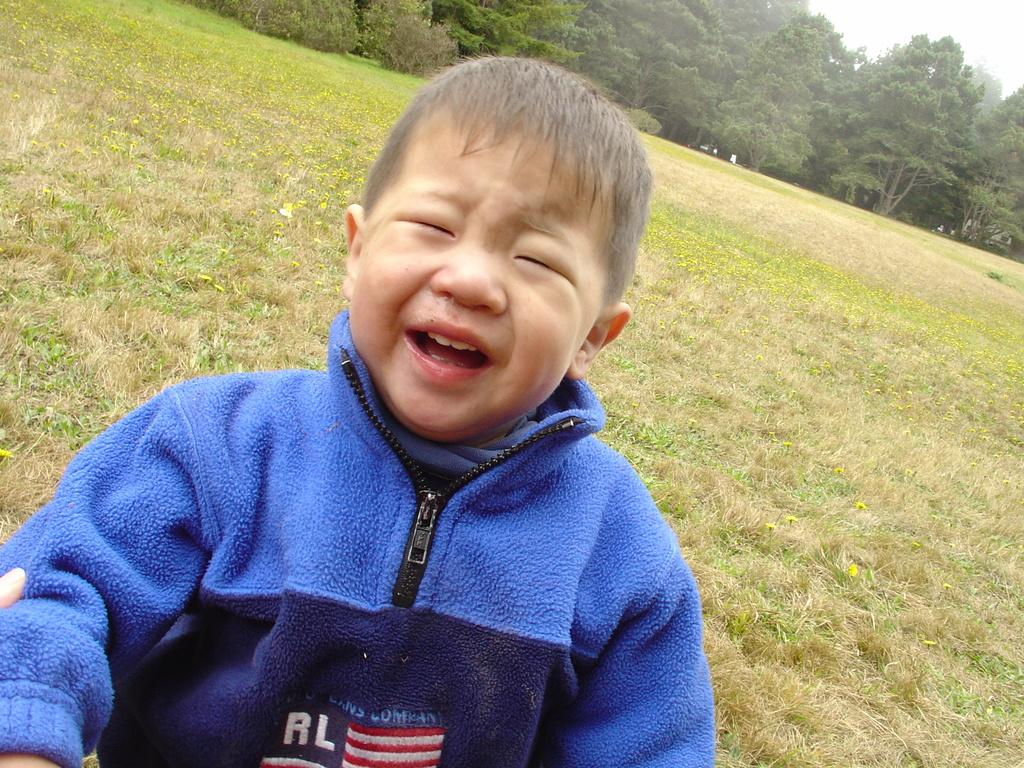What is the main subject of the image? There is a boy in the center of the image. What is the boy doing in the image? The boy is crying. What is the boy wearing in the image? The boy is wearing a blue jacket. What type of vegetation is at the bottom of the image? There is grass at the bottom of the image. What can be seen in the background of the image? There are trees and the sky visible in the background of the image. What type of corn can be seen growing in the image? There is no corn present in the image. What type of coil is wrapped around the boy's neck in the image? There is no coil present in the image. 